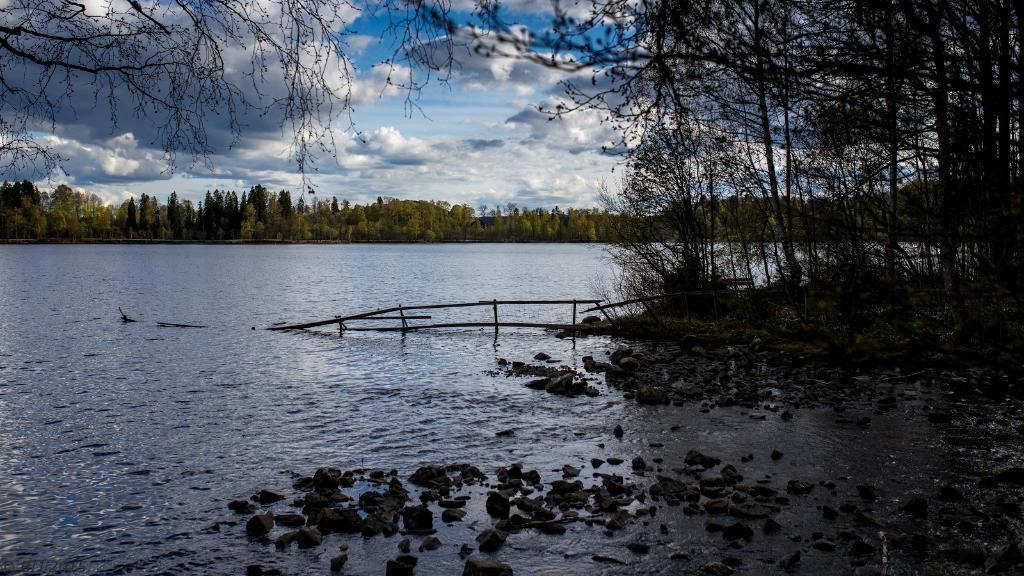What is the primary element in the image? There is water in the image. What other objects or features can be seen in the image? There are stones and trees in the image. What can be seen in the background of the image? The sky is visible in the background of the image. What is the condition of the sky in the image? Clouds are present in the sky. What type of toothpaste is being used to clean the stove in the image? There is no toothpaste or stove present in the image. 